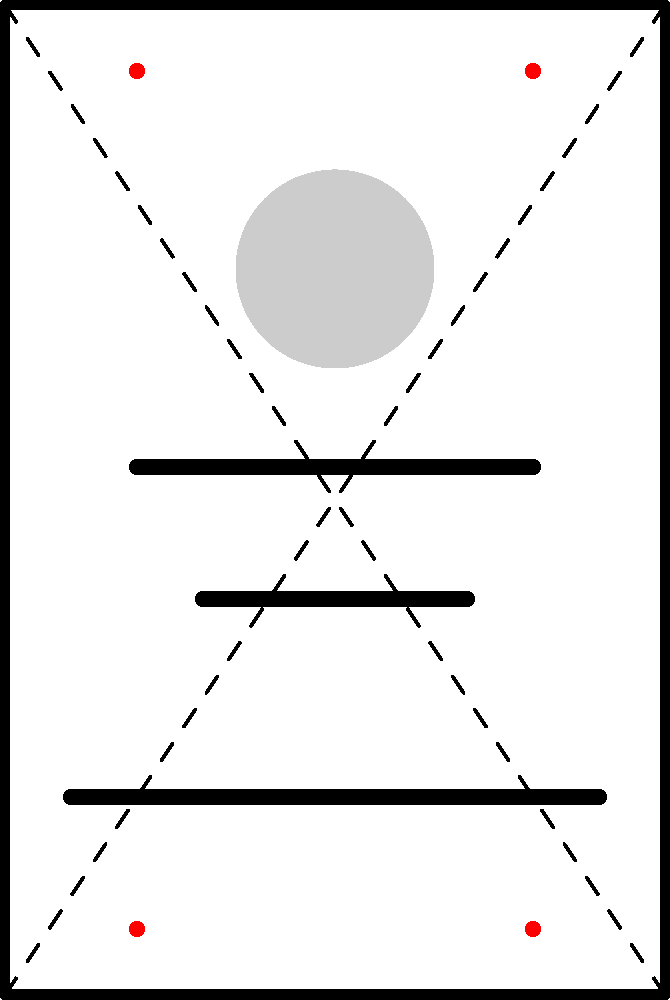Analyze the visual composition of this political campaign poster. How does the arrangement of elements contribute to the poster's message, and what potential biases or manipulations might a critical observer identify in its framing techniques? To analyze this political campaign poster critically, we need to consider several aspects of its visual composition:

1. Rule of Thirds: The poster appears to follow the rule of thirds, with key elements placed along imaginary lines that divide the image into thirds both horizontally and vertically. This creates a more dynamic and engaging composition.

2. Visual Hierarchy: 
   a) The candidate's face (represented by the circle) is placed in the upper third, drawing immediate attention.
   b) Three text lines are positioned below, likely representing the candidate's name and key campaign messages.

3. Balance: The poster uses symmetrical balance, with elements evenly distributed on both sides of the vertical centerline. This can convey stability and trustworthiness but might be perceived as overly rigid or conventional.

4. Framing: The poster uses a simple rectangular frame, which is a classic and neutral choice. However, it doesn't particularly stand out or challenge conventional design norms.

5. Use of Space: There's significant empty space around the main elements, which can either be seen as creating focus or as a missed opportunity to convey more information.

6. Diagonal Lines: The dashed diagonal lines intersect at the center, creating a subtle visual guide that leads the eye to the candidate's face and then down to the text.

7. Visual Weight: The red dots in the corners suggest areas of visual emphasis, potentially indicating where additional design elements or colors might be used to direct attention.

Potential biases or manipulations:
1. Oversimplification: The minimal design might oversimplify complex political issues.
2. Personality Cult: Prominent placement of the candidate's face could be seen as promoting personality over policy.
3. Lack of Context: The absence of background elements removes any real-world context, potentially idealizing the candidate.
4. Emotional Appeal: The symmetry and simplicity might be an attempt to evoke feelings of trust and stability without providing substantive information.
5. Selective Information: The limited text lines suggest highly curated messaging, possibly omitting important details or opposing viewpoints.

A critical observer would question the intentionality behind these design choices and consider how they might influence viewer perception, potentially at the expense of presenting a more comprehensive or balanced political message.
Answer: Symmetrical composition emphasizes candidate centrality; minimal design risks oversimplification and personality focus over policy substance. 